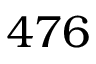<formula> <loc_0><loc_0><loc_500><loc_500>4 7 6</formula> 